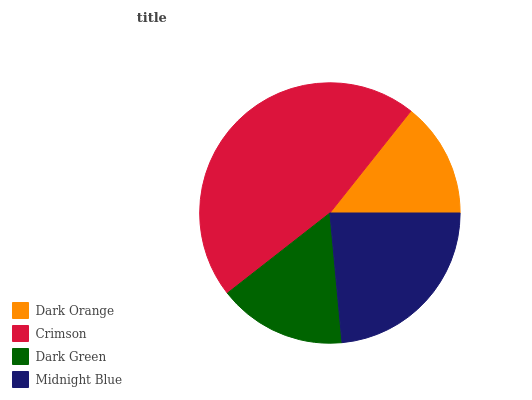Is Dark Orange the minimum?
Answer yes or no. Yes. Is Crimson the maximum?
Answer yes or no. Yes. Is Dark Green the minimum?
Answer yes or no. No. Is Dark Green the maximum?
Answer yes or no. No. Is Crimson greater than Dark Green?
Answer yes or no. Yes. Is Dark Green less than Crimson?
Answer yes or no. Yes. Is Dark Green greater than Crimson?
Answer yes or no. No. Is Crimson less than Dark Green?
Answer yes or no. No. Is Midnight Blue the high median?
Answer yes or no. Yes. Is Dark Green the low median?
Answer yes or no. Yes. Is Crimson the high median?
Answer yes or no. No. Is Dark Orange the low median?
Answer yes or no. No. 